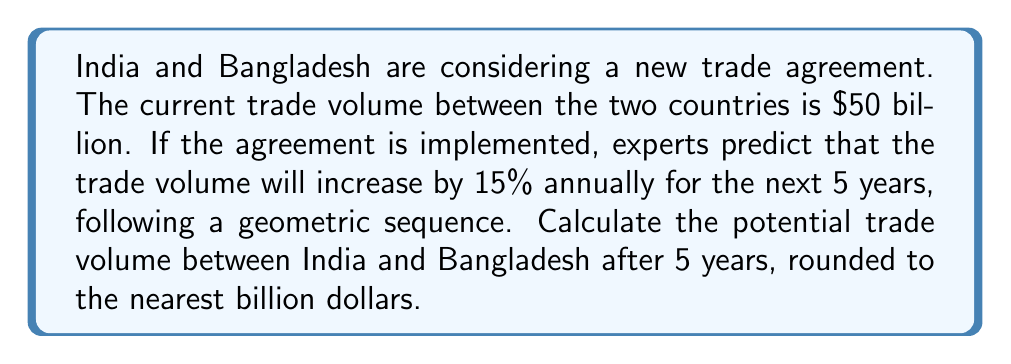Can you answer this question? Let's approach this step-by-step using the geometric sequence formula:

1) The initial term, $a_1 = 50$ billion dollars
2) The common ratio, $r = 1 + 15\% = 1.15$
3) We need to find the 5th term, so $n = 5$

The formula for the nth term of a geometric sequence is:

$$a_n = a_1 \cdot r^{n-1}$$

Substituting our values:

$$a_5 = 50 \cdot (1.15)^{5-1}$$
$$a_5 = 50 \cdot (1.15)^4$$

Now, let's calculate:

$$a_5 = 50 \cdot 1.74900625$$
$$a_5 = 87.450325 \text{ billion dollars}$$

Rounding to the nearest billion:

$$a_5 \approx 87 \text{ billion dollars}$$

Therefore, after 5 years, the potential trade volume between India and Bangladesh would be approximately 87 billion dollars.
Answer: $87 billion 